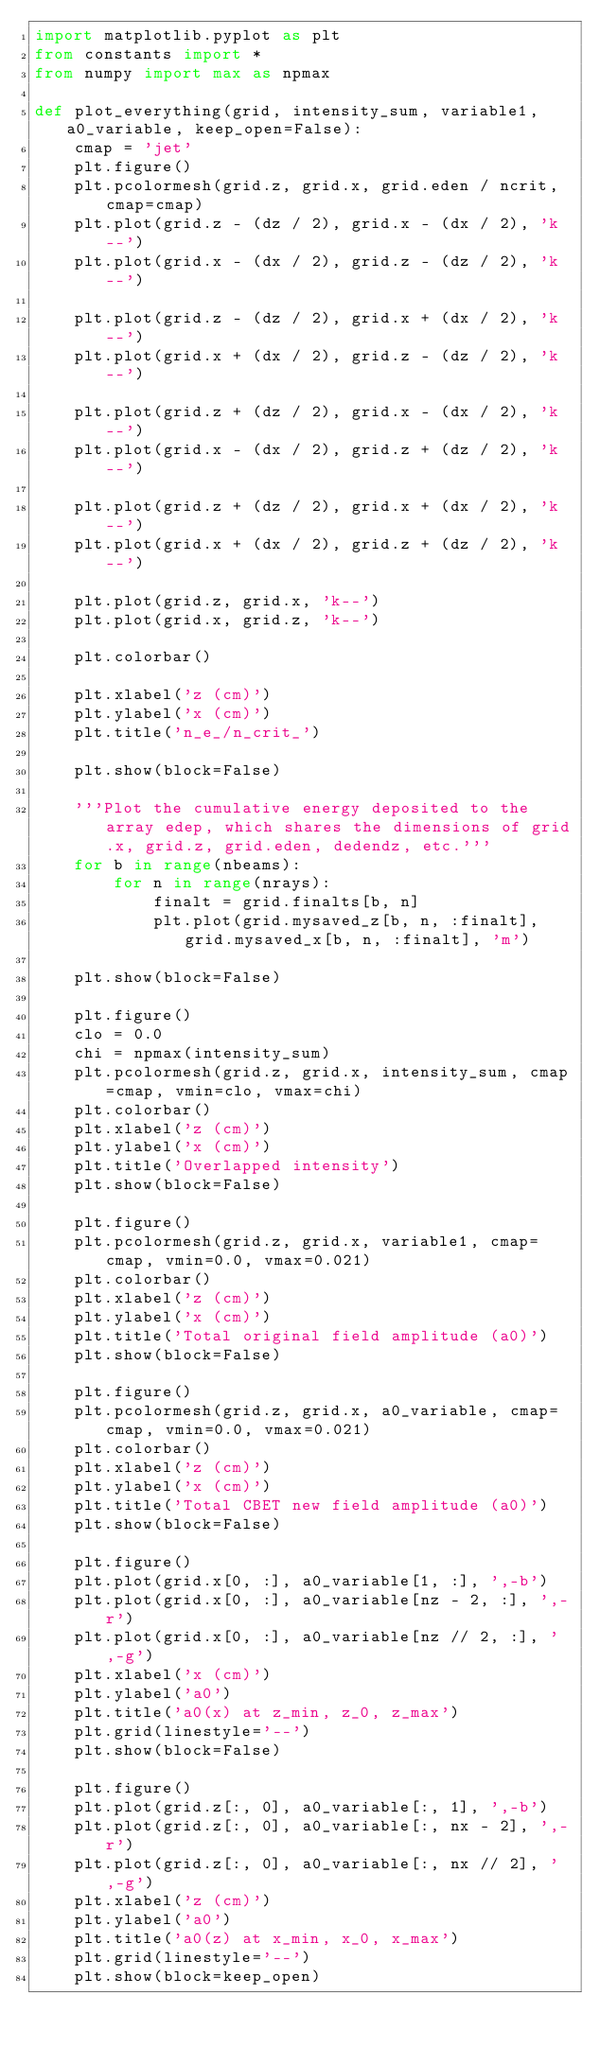<code> <loc_0><loc_0><loc_500><loc_500><_Python_>import matplotlib.pyplot as plt
from constants import *
from numpy import max as npmax

def plot_everything(grid, intensity_sum, variable1, a0_variable, keep_open=False):
    cmap = 'jet'
    plt.figure()
    plt.pcolormesh(grid.z, grid.x, grid.eden / ncrit, cmap=cmap)
    plt.plot(grid.z - (dz / 2), grid.x - (dx / 2), 'k--')
    plt.plot(grid.x - (dx / 2), grid.z - (dz / 2), 'k--')

    plt.plot(grid.z - (dz / 2), grid.x + (dx / 2), 'k--')
    plt.plot(grid.x + (dx / 2), grid.z - (dz / 2), 'k--')

    plt.plot(grid.z + (dz / 2), grid.x - (dx / 2), 'k--')
    plt.plot(grid.x - (dx / 2), grid.z + (dz / 2), 'k--')

    plt.plot(grid.z + (dz / 2), grid.x + (dx / 2), 'k--')
    plt.plot(grid.x + (dx / 2), grid.z + (dz / 2), 'k--')

    plt.plot(grid.z, grid.x, 'k--')
    plt.plot(grid.x, grid.z, 'k--')

    plt.colorbar()

    plt.xlabel('z (cm)')
    plt.ylabel('x (cm)')
    plt.title('n_e_/n_crit_')

    plt.show(block=False)

    '''Plot the cumulative energy deposited to the array edep, which shares the dimensions of grid.x, grid.z, grid.eden, dedendz, etc.'''
    for b in range(nbeams):
        for n in range(nrays):
            finalt = grid.finalts[b, n]
            plt.plot(grid.mysaved_z[b, n, :finalt], grid.mysaved_x[b, n, :finalt], 'm')

    plt.show(block=False)

    plt.figure()
    clo = 0.0
    chi = npmax(intensity_sum)
    plt.pcolormesh(grid.z, grid.x, intensity_sum, cmap=cmap, vmin=clo, vmax=chi)
    plt.colorbar()
    plt.xlabel('z (cm)')
    plt.ylabel('x (cm)')
    plt.title('Overlapped intensity')
    plt.show(block=False)

    plt.figure()
    plt.pcolormesh(grid.z, grid.x, variable1, cmap=cmap, vmin=0.0, vmax=0.021)
    plt.colorbar()
    plt.xlabel('z (cm)')
    plt.ylabel('x (cm)')
    plt.title('Total original field amplitude (a0)')
    plt.show(block=False)

    plt.figure()
    plt.pcolormesh(grid.z, grid.x, a0_variable, cmap=cmap, vmin=0.0, vmax=0.021)
    plt.colorbar()
    plt.xlabel('z (cm)')
    plt.ylabel('x (cm)')
    plt.title('Total CBET new field amplitude (a0)')
    plt.show(block=False)

    plt.figure()
    plt.plot(grid.x[0, :], a0_variable[1, :], ',-b')
    plt.plot(grid.x[0, :], a0_variable[nz - 2, :], ',-r')
    plt.plot(grid.x[0, :], a0_variable[nz // 2, :], ',-g')
    plt.xlabel('x (cm)')
    plt.ylabel('a0')
    plt.title('a0(x) at z_min, z_0, z_max')
    plt.grid(linestyle='--')
    plt.show(block=False)

    plt.figure()
    plt.plot(grid.z[:, 0], a0_variable[:, 1], ',-b')
    plt.plot(grid.z[:, 0], a0_variable[:, nx - 2], ',-r')
    plt.plot(grid.z[:, 0], a0_variable[:, nx // 2], ',-g')
    plt.xlabel('z (cm)')
    plt.ylabel('a0')
    plt.title('a0(z) at x_min, x_0, x_max')
    plt.grid(linestyle='--')
    plt.show(block=keep_open)
</code> 